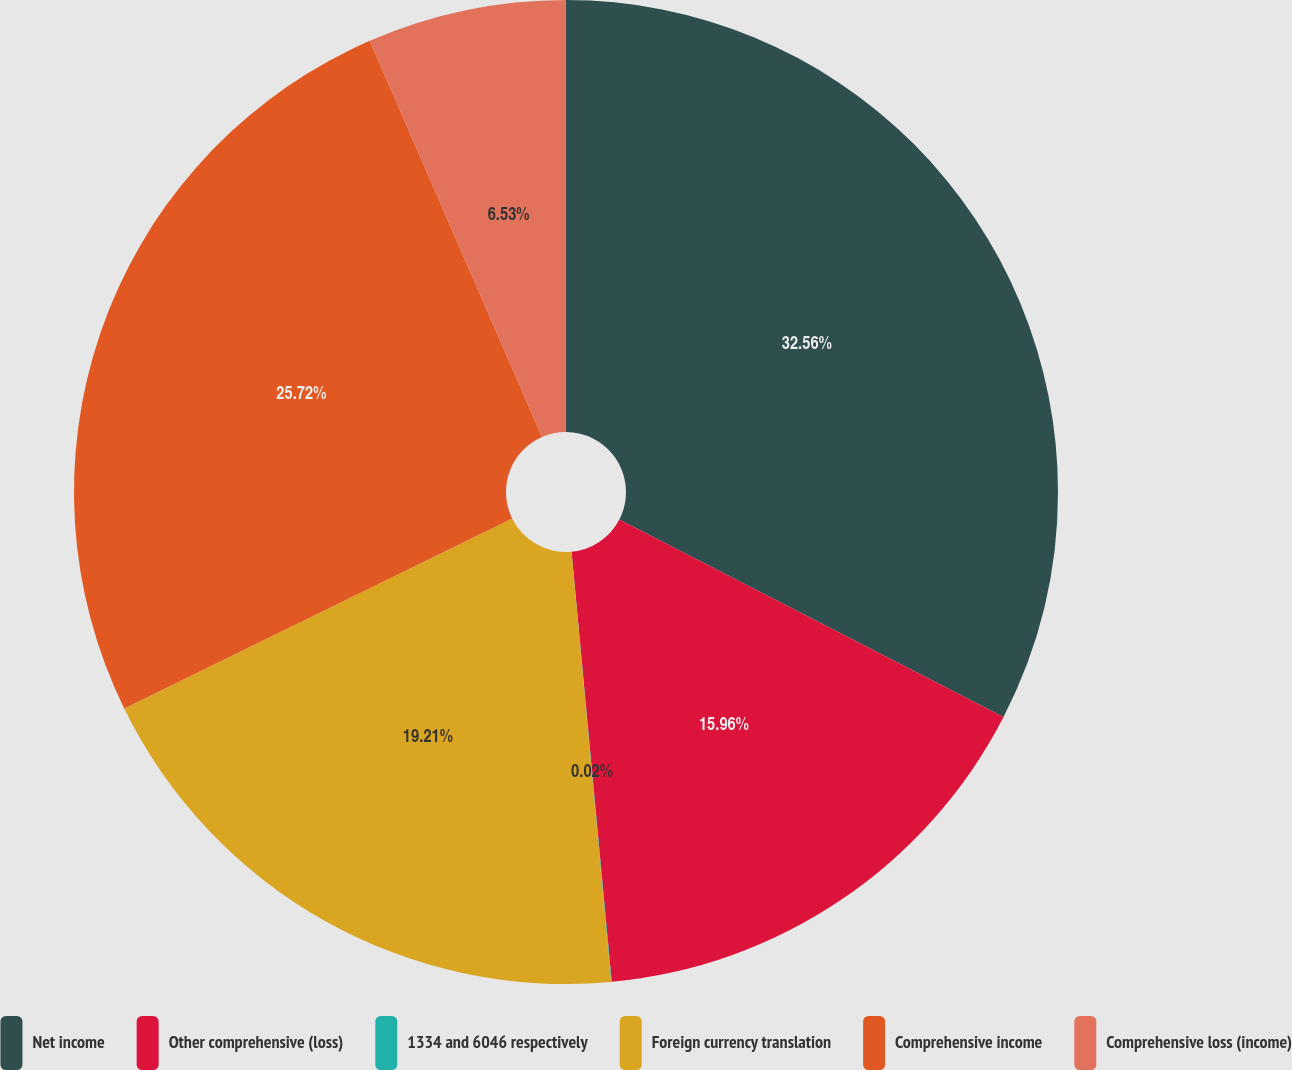<chart> <loc_0><loc_0><loc_500><loc_500><pie_chart><fcel>Net income<fcel>Other comprehensive (loss)<fcel>1334 and 6046 respectively<fcel>Foreign currency translation<fcel>Comprehensive income<fcel>Comprehensive loss (income)<nl><fcel>32.56%<fcel>15.96%<fcel>0.02%<fcel>19.21%<fcel>25.72%<fcel>6.53%<nl></chart> 